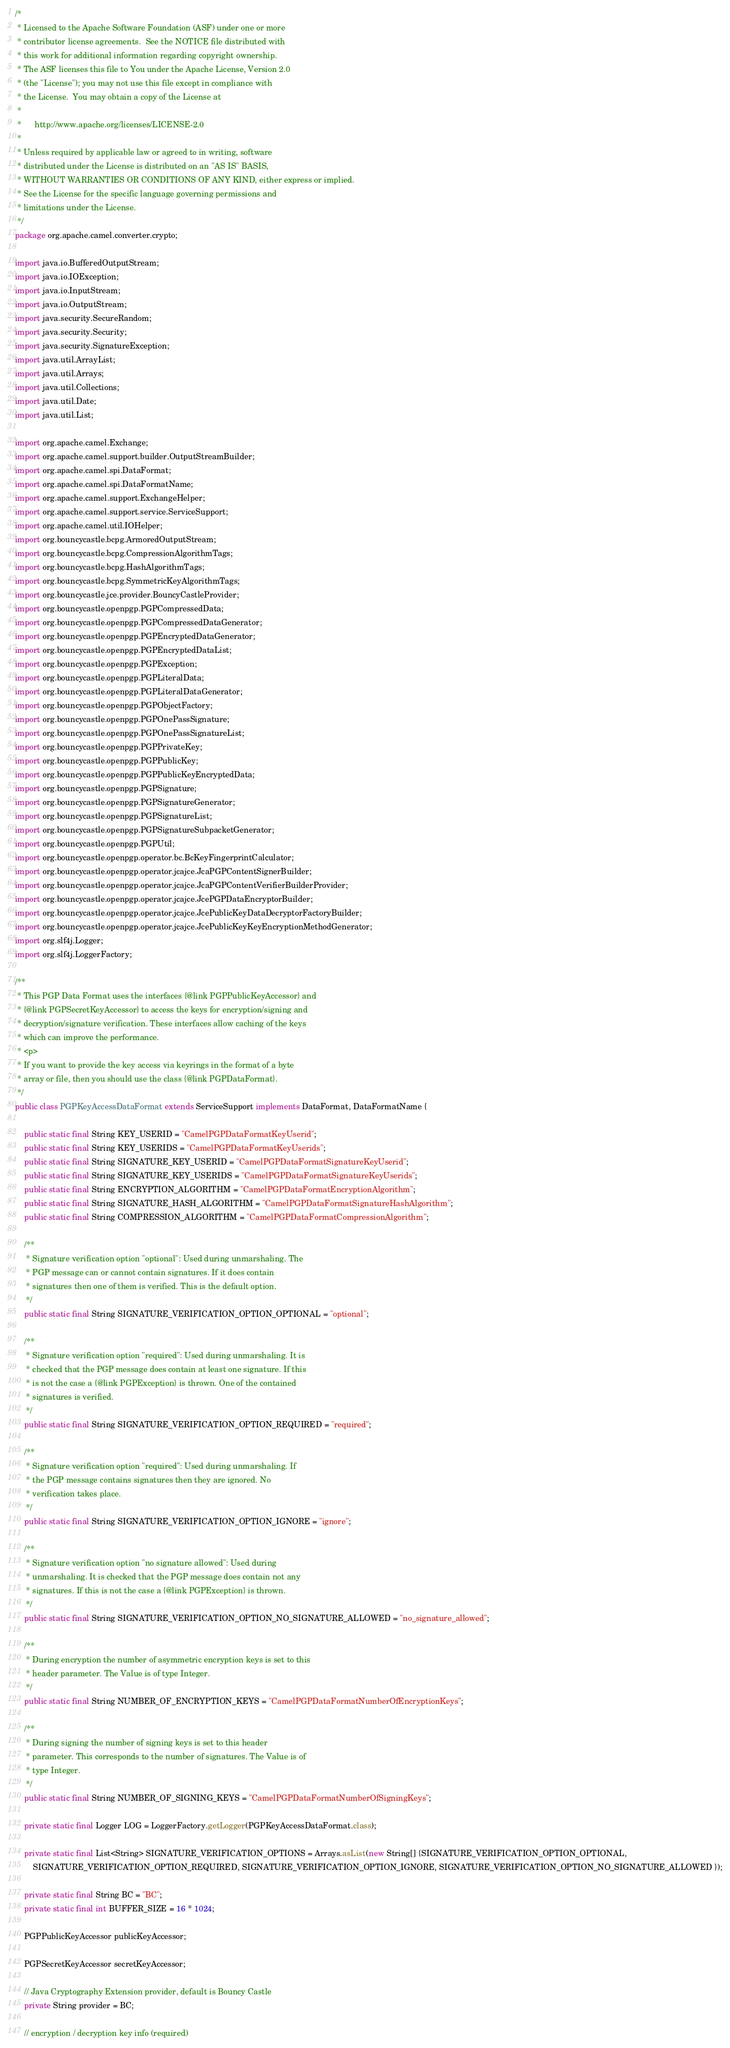<code> <loc_0><loc_0><loc_500><loc_500><_Java_>/*
 * Licensed to the Apache Software Foundation (ASF) under one or more
 * contributor license agreements.  See the NOTICE file distributed with
 * this work for additional information regarding copyright ownership.
 * The ASF licenses this file to You under the Apache License, Version 2.0
 * (the "License"); you may not use this file except in compliance with
 * the License.  You may obtain a copy of the License at
 *
 *      http://www.apache.org/licenses/LICENSE-2.0
 *
 * Unless required by applicable law or agreed to in writing, software
 * distributed under the License is distributed on an "AS IS" BASIS,
 * WITHOUT WARRANTIES OR CONDITIONS OF ANY KIND, either express or implied.
 * See the License for the specific language governing permissions and
 * limitations under the License.
 */
package org.apache.camel.converter.crypto;

import java.io.BufferedOutputStream;
import java.io.IOException;
import java.io.InputStream;
import java.io.OutputStream;
import java.security.SecureRandom;
import java.security.Security;
import java.security.SignatureException;
import java.util.ArrayList;
import java.util.Arrays;
import java.util.Collections;
import java.util.Date;
import java.util.List;

import org.apache.camel.Exchange;
import org.apache.camel.support.builder.OutputStreamBuilder;
import org.apache.camel.spi.DataFormat;
import org.apache.camel.spi.DataFormatName;
import org.apache.camel.support.ExchangeHelper;
import org.apache.camel.support.service.ServiceSupport;
import org.apache.camel.util.IOHelper;
import org.bouncycastle.bcpg.ArmoredOutputStream;
import org.bouncycastle.bcpg.CompressionAlgorithmTags;
import org.bouncycastle.bcpg.HashAlgorithmTags;
import org.bouncycastle.bcpg.SymmetricKeyAlgorithmTags;
import org.bouncycastle.jce.provider.BouncyCastleProvider;
import org.bouncycastle.openpgp.PGPCompressedData;
import org.bouncycastle.openpgp.PGPCompressedDataGenerator;
import org.bouncycastle.openpgp.PGPEncryptedDataGenerator;
import org.bouncycastle.openpgp.PGPEncryptedDataList;
import org.bouncycastle.openpgp.PGPException;
import org.bouncycastle.openpgp.PGPLiteralData;
import org.bouncycastle.openpgp.PGPLiteralDataGenerator;
import org.bouncycastle.openpgp.PGPObjectFactory;
import org.bouncycastle.openpgp.PGPOnePassSignature;
import org.bouncycastle.openpgp.PGPOnePassSignatureList;
import org.bouncycastle.openpgp.PGPPrivateKey;
import org.bouncycastle.openpgp.PGPPublicKey;
import org.bouncycastle.openpgp.PGPPublicKeyEncryptedData;
import org.bouncycastle.openpgp.PGPSignature;
import org.bouncycastle.openpgp.PGPSignatureGenerator;
import org.bouncycastle.openpgp.PGPSignatureList;
import org.bouncycastle.openpgp.PGPSignatureSubpacketGenerator;
import org.bouncycastle.openpgp.PGPUtil;
import org.bouncycastle.openpgp.operator.bc.BcKeyFingerprintCalculator;
import org.bouncycastle.openpgp.operator.jcajce.JcaPGPContentSignerBuilder;
import org.bouncycastle.openpgp.operator.jcajce.JcaPGPContentVerifierBuilderProvider;
import org.bouncycastle.openpgp.operator.jcajce.JcePGPDataEncryptorBuilder;
import org.bouncycastle.openpgp.operator.jcajce.JcePublicKeyDataDecryptorFactoryBuilder;
import org.bouncycastle.openpgp.operator.jcajce.JcePublicKeyKeyEncryptionMethodGenerator;
import org.slf4j.Logger;
import org.slf4j.LoggerFactory;

/**
 * This PGP Data Format uses the interfaces {@link PGPPublicKeyAccessor} and
 * {@link PGPSecretKeyAccessor} to access the keys for encryption/signing and
 * decryption/signature verification. These interfaces allow caching of the keys
 * which can improve the performance.
 * <p>
 * If you want to provide the key access via keyrings in the format of a byte
 * array or file, then you should use the class {@link PGPDataFormat}.
 */
public class PGPKeyAccessDataFormat extends ServiceSupport implements DataFormat, DataFormatName {

    public static final String KEY_USERID = "CamelPGPDataFormatKeyUserid";
    public static final String KEY_USERIDS = "CamelPGPDataFormatKeyUserids";
    public static final String SIGNATURE_KEY_USERID = "CamelPGPDataFormatSignatureKeyUserid";
    public static final String SIGNATURE_KEY_USERIDS = "CamelPGPDataFormatSignatureKeyUserids";
    public static final String ENCRYPTION_ALGORITHM = "CamelPGPDataFormatEncryptionAlgorithm";
    public static final String SIGNATURE_HASH_ALGORITHM = "CamelPGPDataFormatSignatureHashAlgorithm";
    public static final String COMPRESSION_ALGORITHM = "CamelPGPDataFormatCompressionAlgorithm";

    /**
     * Signature verification option "optional": Used during unmarshaling. The
     * PGP message can or cannot contain signatures. If it does contain
     * signatures then one of them is verified. This is the default option.
     */
    public static final String SIGNATURE_VERIFICATION_OPTION_OPTIONAL = "optional";

    /**
     * Signature verification option "required": Used during unmarshaling. It is
     * checked that the PGP message does contain at least one signature. If this
     * is not the case a {@link PGPException} is thrown. One of the contained 
     * signatures is verified.
     */
    public static final String SIGNATURE_VERIFICATION_OPTION_REQUIRED = "required";
    
    /**
     * Signature verification option "required": Used during unmarshaling. If 
     * the PGP message contains signatures then they are ignored. No 
     * verification takes place.
     */
    public static final String SIGNATURE_VERIFICATION_OPTION_IGNORE = "ignore";

    /**
     * Signature verification option "no signature allowed": Used during
     * unmarshaling. It is checked that the PGP message does contain not any
     * signatures. If this is not the case a {@link PGPException} is thrown.
     */
    public static final String SIGNATURE_VERIFICATION_OPTION_NO_SIGNATURE_ALLOWED = "no_signature_allowed";

    /**
     * During encryption the number of asymmetric encryption keys is set to this
     * header parameter. The Value is of type Integer.
     */
    public static final String NUMBER_OF_ENCRYPTION_KEYS = "CamelPGPDataFormatNumberOfEncryptionKeys";

    /**
     * During signing the number of signing keys is set to this header
     * parameter. This corresponds to the number of signatures. The Value is of
     * type Integer.
     */
    public static final String NUMBER_OF_SIGNING_KEYS = "CamelPGPDataFormatNumberOfSigningKeys";

    private static final Logger LOG = LoggerFactory.getLogger(PGPKeyAccessDataFormat.class);

    private static final List<String> SIGNATURE_VERIFICATION_OPTIONS = Arrays.asList(new String[] {SIGNATURE_VERIFICATION_OPTION_OPTIONAL,
        SIGNATURE_VERIFICATION_OPTION_REQUIRED, SIGNATURE_VERIFICATION_OPTION_IGNORE, SIGNATURE_VERIFICATION_OPTION_NO_SIGNATURE_ALLOWED });

    private static final String BC = "BC";
    private static final int BUFFER_SIZE = 16 * 1024;

    PGPPublicKeyAccessor publicKeyAccessor;

    PGPSecretKeyAccessor secretKeyAccessor;

    // Java Cryptography Extension provider, default is Bouncy Castle
    private String provider = BC;

    // encryption / decryption key info (required)</code> 